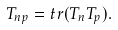<formula> <loc_0><loc_0><loc_500><loc_500>T _ { n p } = t r ( T _ { n } T _ { p } ) .</formula> 